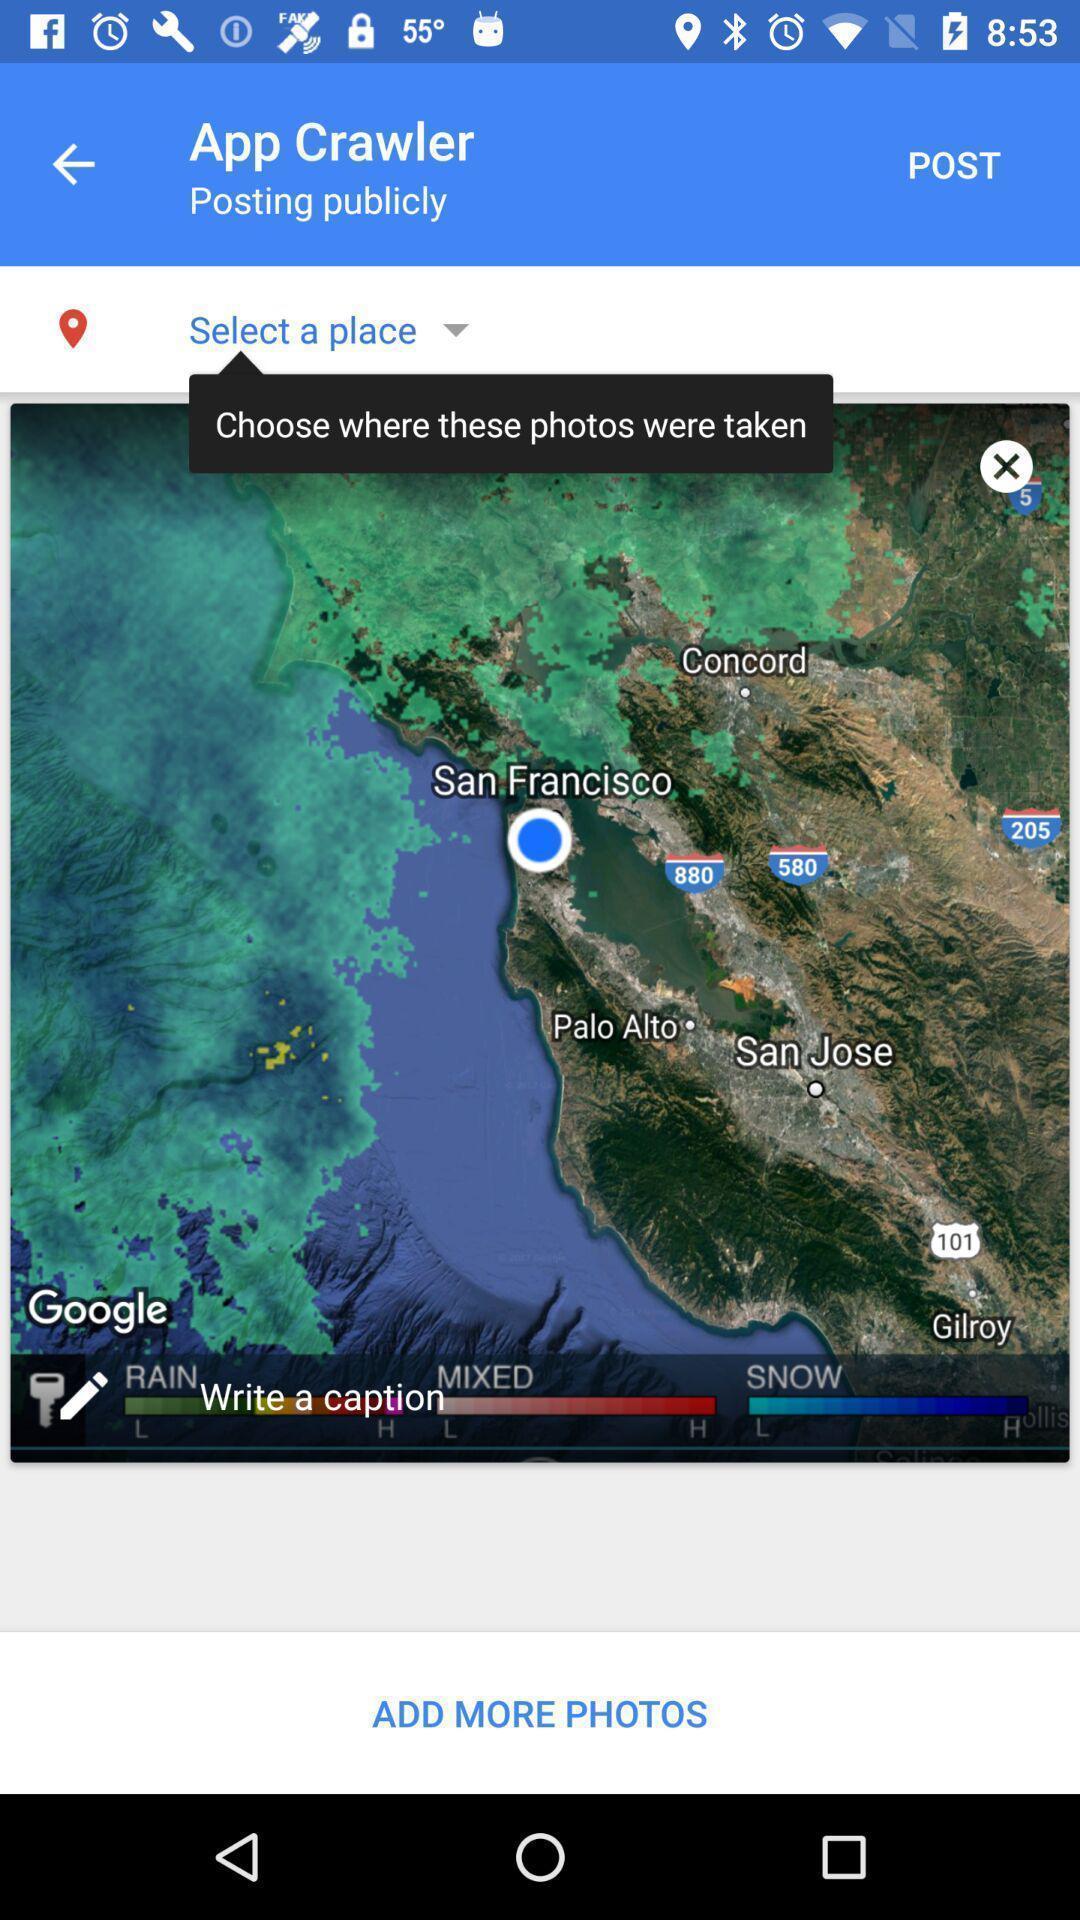Give me a narrative description of this picture. Select a place in app crawler in maps. 